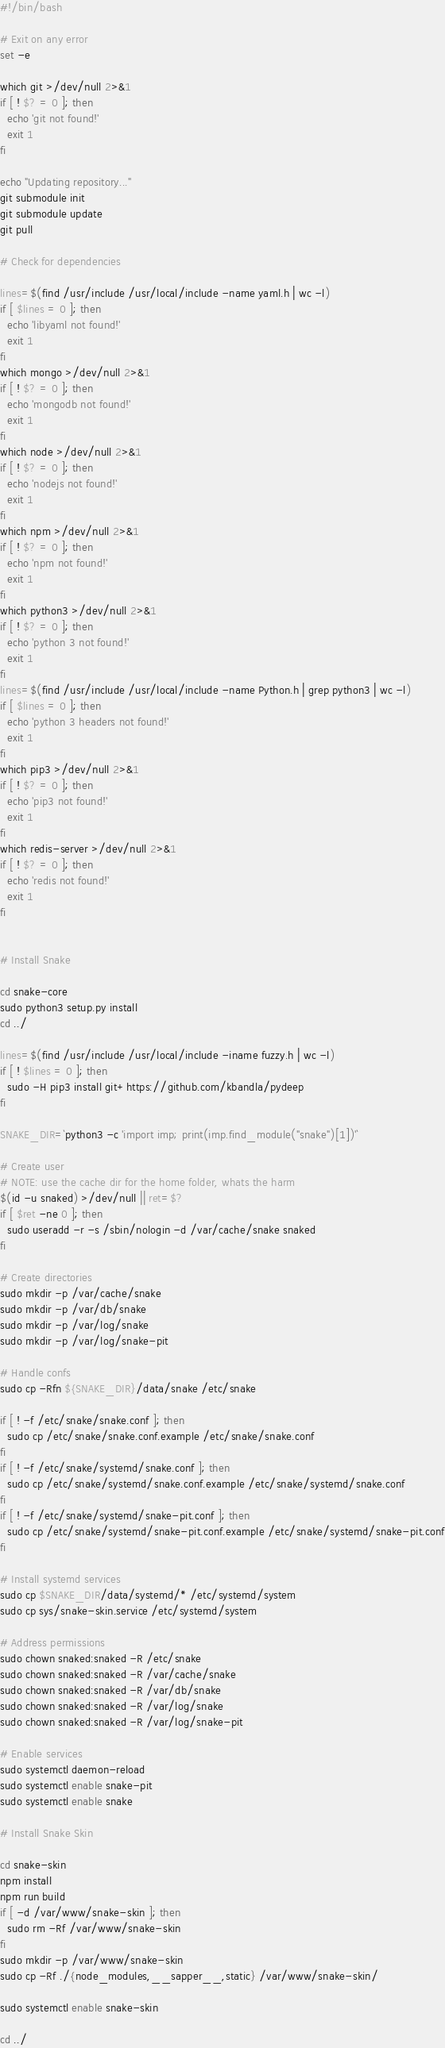<code> <loc_0><loc_0><loc_500><loc_500><_Bash_>#!/bin/bash

# Exit on any error
set -e

which git >/dev/null 2>&1
if [ ! $? = 0 ]; then
  echo 'git not found!'
  exit 1
fi

echo "Updating repository..."
git submodule init
git submodule update
git pull

# Check for dependencies

lines=$(find /usr/include /usr/local/include -name yaml.h | wc -l)
if [ $lines = 0 ]; then
  echo 'libyaml not found!'
  exit 1
fi
which mongo >/dev/null 2>&1
if [ ! $? = 0 ]; then
  echo 'mongodb not found!'
  exit 1
fi
which node >/dev/null 2>&1
if [ ! $? = 0 ]; then
  echo 'nodejs not found!'
  exit 1
fi
which npm >/dev/null 2>&1
if [ ! $? = 0 ]; then
  echo 'npm not found!'
  exit 1
fi
which python3 >/dev/null 2>&1
if [ ! $? = 0 ]; then
  echo 'python 3 not found!'
  exit 1
fi
lines=$(find /usr/include /usr/local/include -name Python.h | grep python3 | wc -l)
if [ $lines = 0 ]; then
  echo 'python 3 headers not found!'
  exit 1
fi
which pip3 >/dev/null 2>&1
if [ ! $? = 0 ]; then
  echo 'pip3 not found!'
  exit 1
fi
which redis-server >/dev/null 2>&1
if [ ! $? = 0 ]; then
  echo 'redis not found!'
  exit 1
fi


# Install Snake

cd snake-core
sudo python3 setup.py install
cd ../

lines=$(find /usr/include /usr/local/include -iname fuzzy.h | wc -l)
if [ ! $lines = 0 ]; then
  sudo -H pip3 install git+https://github.com/kbandla/pydeep
fi

SNAKE_DIR=`python3 -c 'import imp; print(imp.find_module("snake")[1])'`

# Create user
# NOTE: use the cache dir for the home folder, whats the harm
$(id -u snaked) >/dev/null || ret=$?
if [ $ret -ne 0 ]; then
  sudo useradd -r -s /sbin/nologin -d /var/cache/snake snaked
fi

# Create directories
sudo mkdir -p /var/cache/snake
sudo mkdir -p /var/db/snake
sudo mkdir -p /var/log/snake
sudo mkdir -p /var/log/snake-pit

# Handle confs
sudo cp -Rfn ${SNAKE_DIR}/data/snake /etc/snake

if [ ! -f /etc/snake/snake.conf ]; then
  sudo cp /etc/snake/snake.conf.example /etc/snake/snake.conf
fi
if [ ! -f /etc/snake/systemd/snake.conf ]; then
  sudo cp /etc/snake/systemd/snake.conf.example /etc/snake/systemd/snake.conf
fi
if [ ! -f /etc/snake/systemd/snake-pit.conf ]; then
  sudo cp /etc/snake/systemd/snake-pit.conf.example /etc/snake/systemd/snake-pit.conf
fi

# Install systemd services
sudo cp $SNAKE_DIR/data/systemd/* /etc/systemd/system
sudo cp sys/snake-skin.service /etc/systemd/system

# Address permissions
sudo chown snaked:snaked -R /etc/snake
sudo chown snaked:snaked -R /var/cache/snake
sudo chown snaked:snaked -R /var/db/snake
sudo chown snaked:snaked -R /var/log/snake
sudo chown snaked:snaked -R /var/log/snake-pit

# Enable services
sudo systemctl daemon-reload
sudo systemctl enable snake-pit
sudo systemctl enable snake

# Install Snake Skin

cd snake-skin
npm install
npm run build
if [ -d /var/www/snake-skin ]; then
  sudo rm -Rf /var/www/snake-skin
fi
sudo mkdir -p /var/www/snake-skin
sudo cp -Rf ./{node_modules,__sapper__,static} /var/www/snake-skin/

sudo systemctl enable snake-skin

cd ../
</code> 